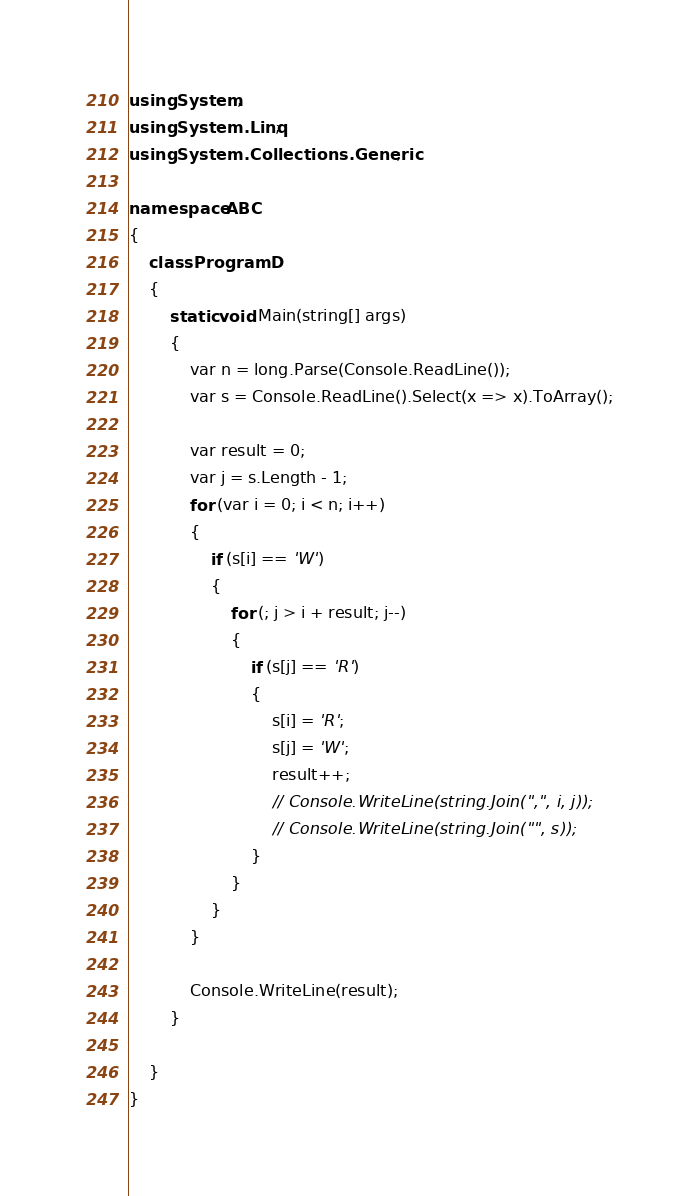Convert code to text. <code><loc_0><loc_0><loc_500><loc_500><_C#_>using System;
using System.Linq;
using System.Collections.Generic;

namespace ABC
{
    class ProgramD
    {
        static void Main(string[] args)
        {
            var n = long.Parse(Console.ReadLine());
            var s = Console.ReadLine().Select(x => x).ToArray();

            var result = 0;
            var j = s.Length - 1;
            for (var i = 0; i < n; i++)
            {
                if (s[i] == 'W')
                {
                    for (; j > i + result; j--)
                    {
                        if (s[j] == 'R')
                        {
                            s[i] = 'R';
                            s[j] = 'W';
                            result++;
                            // Console.WriteLine(string.Join(",", i, j));
                            // Console.WriteLine(string.Join("", s));
                        }
                    }
                }
            }

            Console.WriteLine(result);
        }

    }
}
</code> 